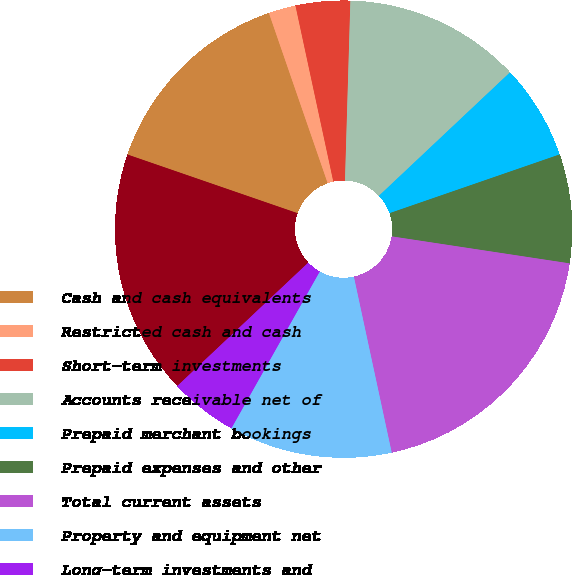<chart> <loc_0><loc_0><loc_500><loc_500><pie_chart><fcel>Cash and cash equivalents<fcel>Restricted cash and cash<fcel>Short-term investments<fcel>Accounts receivable net of<fcel>Prepaid merchant bookings<fcel>Prepaid expenses and other<fcel>Total current assets<fcel>Property and equipment net<fcel>Long-term investments and<fcel>Intangible assets net<nl><fcel>14.42%<fcel>1.92%<fcel>3.85%<fcel>12.5%<fcel>6.73%<fcel>7.69%<fcel>19.23%<fcel>11.54%<fcel>4.81%<fcel>17.31%<nl></chart> 